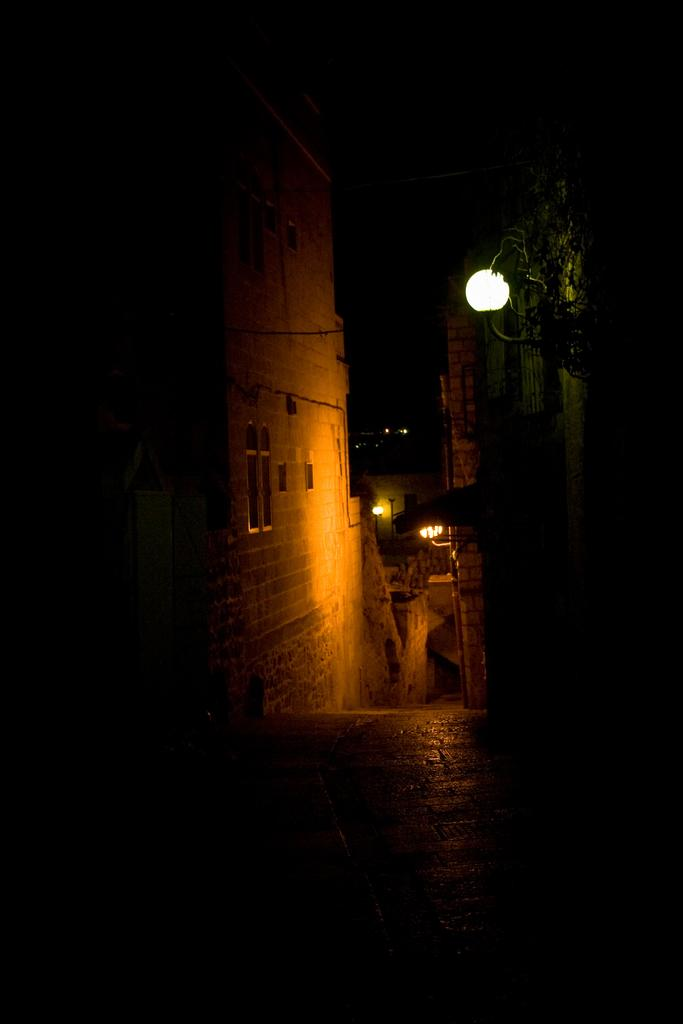What type of structures can be seen in the image? There are buildings in the image. What is the purpose of the object on the street in the image? The object on the street is a street light, which provides illumination. What part of the natural environment is visible in the image? The sky is visible in the image. What type of meat is hanging from the street light in the image? There is no meat present in the image; the object on the street is a street light, not a source of meat. 